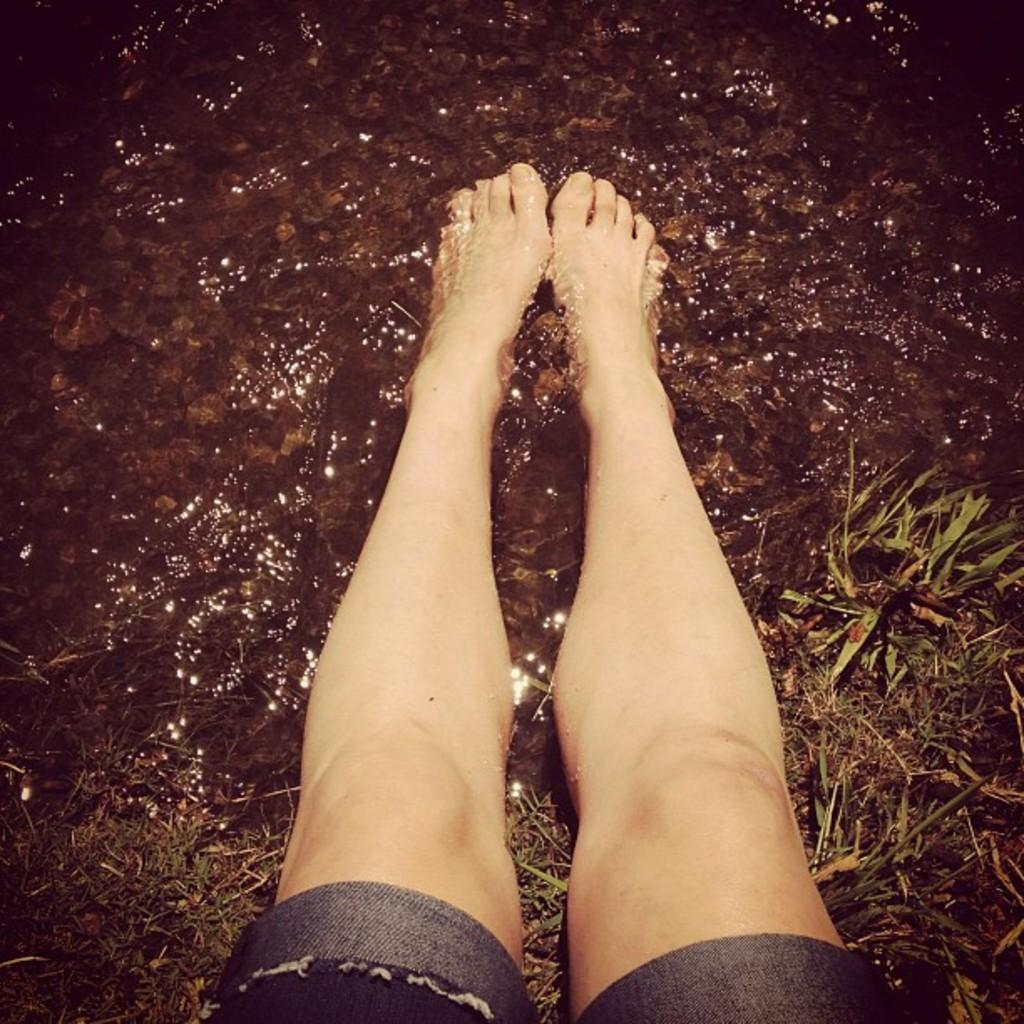What part of a person can be seen in the image? There are legs of a person in the image. What type of terrain is visible in the image? Grass and water are visible in the image. What type of natural elements can be seen in the image? There are stones in the image. What type of skirt is the person wearing in the image? There is no skirt visible in the image, as only the legs of the person are shown. 